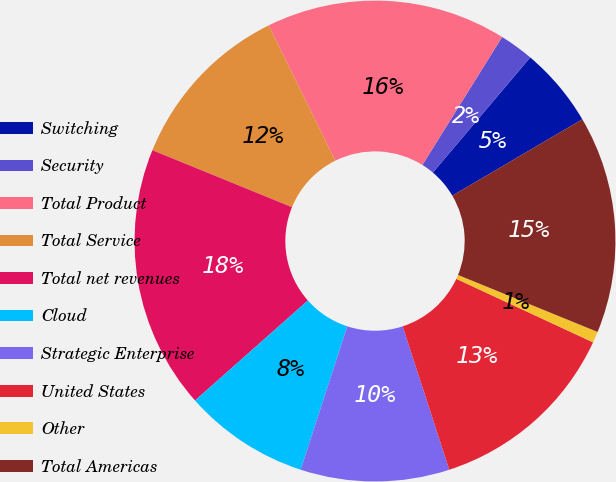Convert chart to OTSL. <chart><loc_0><loc_0><loc_500><loc_500><pie_chart><fcel>Switching<fcel>Security<fcel>Total Product<fcel>Total Service<fcel>Total net revenues<fcel>Cloud<fcel>Strategic Enterprise<fcel>United States<fcel>Other<fcel>Total Americas<nl><fcel>5.38%<fcel>2.3%<fcel>16.16%<fcel>11.54%<fcel>17.7%<fcel>8.46%<fcel>10.0%<fcel>13.08%<fcel>0.75%<fcel>14.62%<nl></chart> 